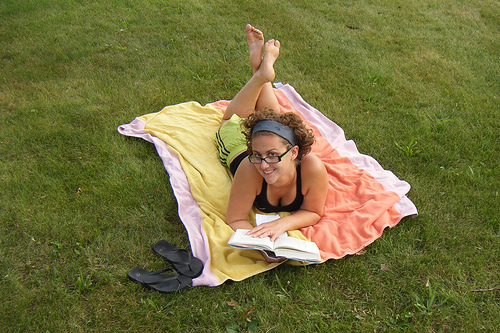<image>
Is there a bed sheet on the grass? Yes. Looking at the image, I can see the bed sheet is positioned on top of the grass, with the grass providing support. Is the towel on the grass? Yes. Looking at the image, I can see the towel is positioned on top of the grass, with the grass providing support. Is there a women on the grass? Yes. Looking at the image, I can see the women is positioned on top of the grass, with the grass providing support. 